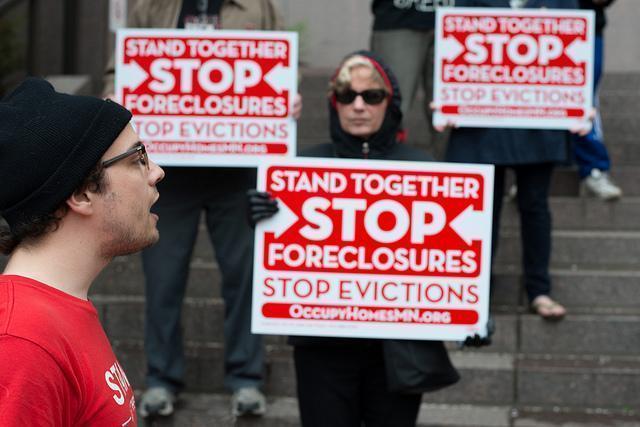What might the item on the woman's face be used to shield from?
From the following four choices, select the correct answer to address the question.
Options: Punches, sun, rain, bees. Sun. 